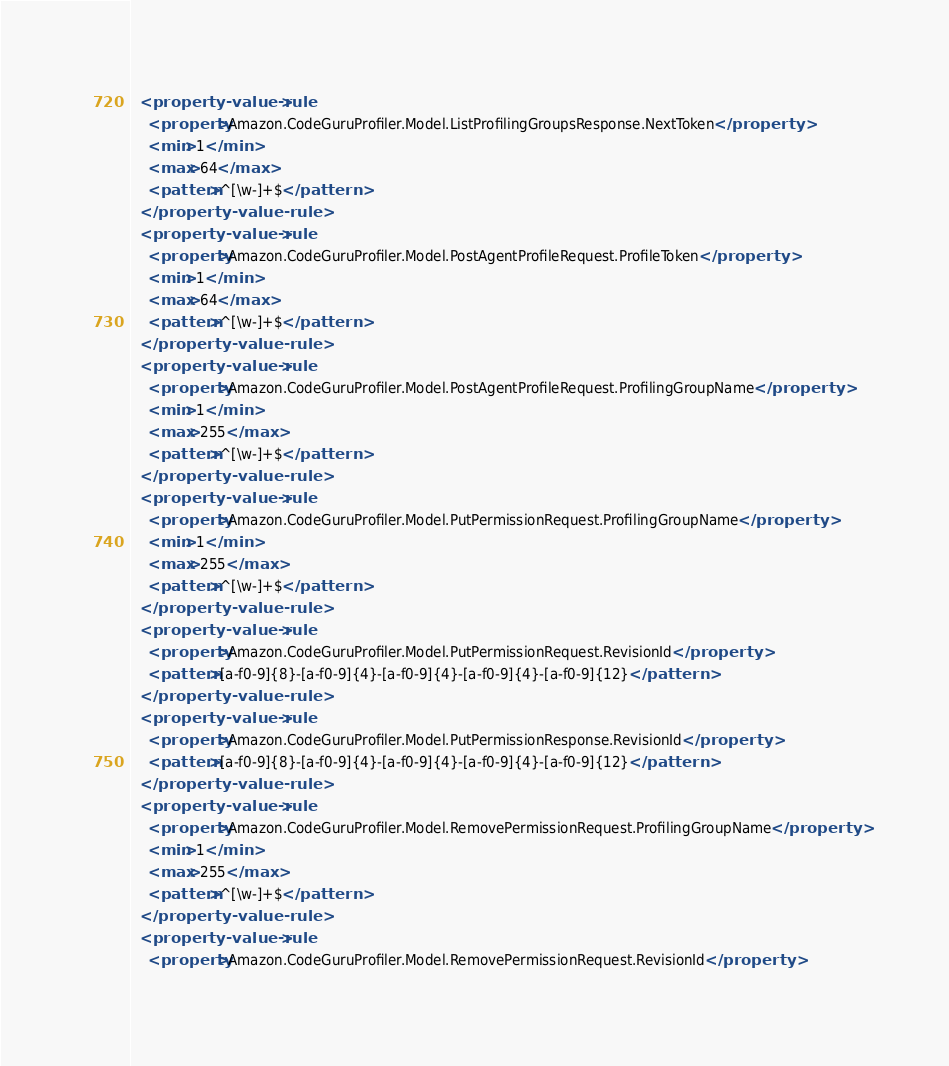Convert code to text. <code><loc_0><loc_0><loc_500><loc_500><_XML_>  <property-value-rule>
    <property>Amazon.CodeGuruProfiler.Model.ListProfilingGroupsResponse.NextToken</property>
    <min>1</min>
    <max>64</max>
    <pattern>^[\w-]+$</pattern>
  </property-value-rule>
  <property-value-rule>
    <property>Amazon.CodeGuruProfiler.Model.PostAgentProfileRequest.ProfileToken</property>
    <min>1</min>
    <max>64</max>
    <pattern>^[\w-]+$</pattern>
  </property-value-rule>
  <property-value-rule>
    <property>Amazon.CodeGuruProfiler.Model.PostAgentProfileRequest.ProfilingGroupName</property>
    <min>1</min>
    <max>255</max>
    <pattern>^[\w-]+$</pattern>
  </property-value-rule>
  <property-value-rule>
    <property>Amazon.CodeGuruProfiler.Model.PutPermissionRequest.ProfilingGroupName</property>
    <min>1</min>
    <max>255</max>
    <pattern>^[\w-]+$</pattern>
  </property-value-rule>
  <property-value-rule>
    <property>Amazon.CodeGuruProfiler.Model.PutPermissionRequest.RevisionId</property>
    <pattern>[a-f0-9]{8}-[a-f0-9]{4}-[a-f0-9]{4}-[a-f0-9]{4}-[a-f0-9]{12}</pattern>
  </property-value-rule>
  <property-value-rule>
    <property>Amazon.CodeGuruProfiler.Model.PutPermissionResponse.RevisionId</property>
    <pattern>[a-f0-9]{8}-[a-f0-9]{4}-[a-f0-9]{4}-[a-f0-9]{4}-[a-f0-9]{12}</pattern>
  </property-value-rule>
  <property-value-rule>
    <property>Amazon.CodeGuruProfiler.Model.RemovePermissionRequest.ProfilingGroupName</property>
    <min>1</min>
    <max>255</max>
    <pattern>^[\w-]+$</pattern>
  </property-value-rule>
  <property-value-rule>
    <property>Amazon.CodeGuruProfiler.Model.RemovePermissionRequest.RevisionId</property></code> 